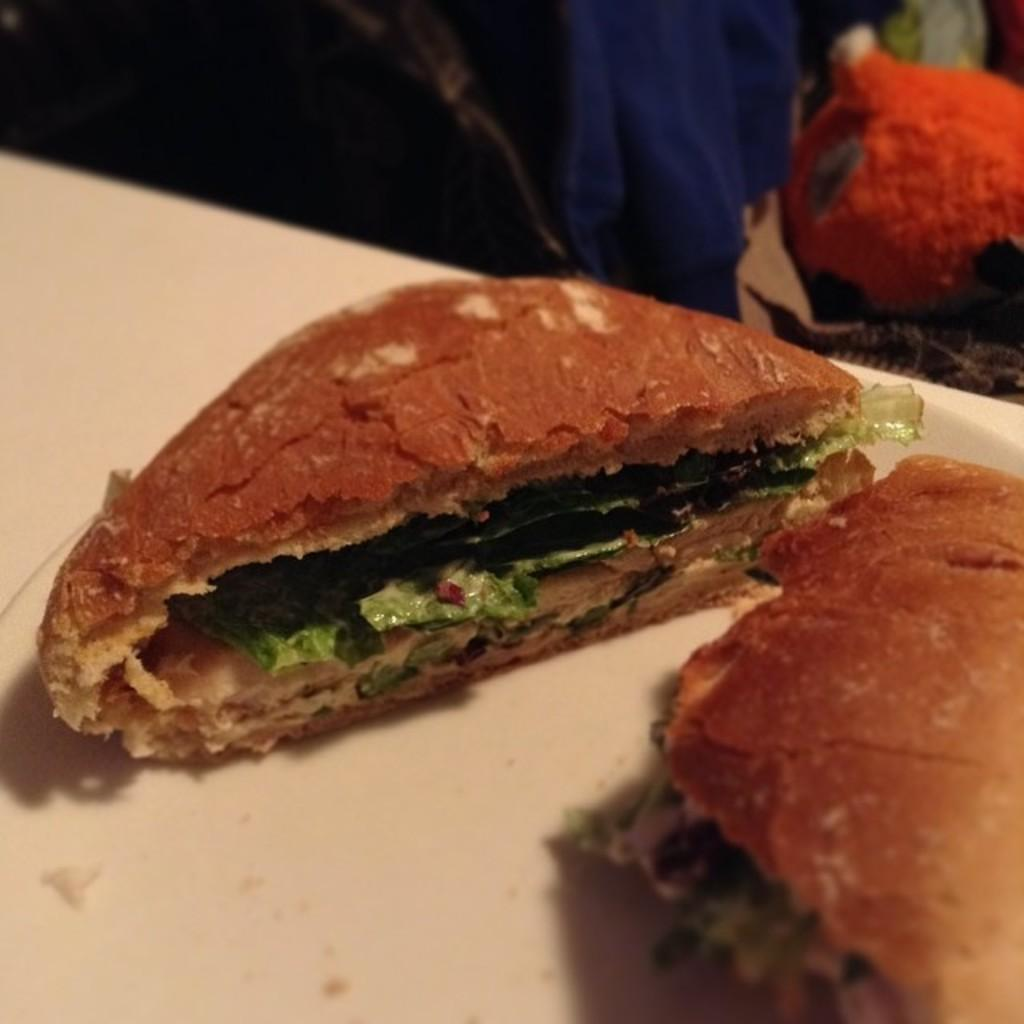What is present on the surface in the image? There is food on a surface in the image. What type of flesh can be seen on the plantation in the image? There is no flesh or plantation present in the image; it only features food on a surface. 